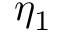<formula> <loc_0><loc_0><loc_500><loc_500>\eta _ { 1 }</formula> 